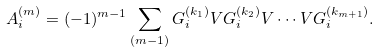<formula> <loc_0><loc_0><loc_500><loc_500>A _ { i } ^ { ( m ) } = ( - 1 ) ^ { m - 1 } \sum _ { ( m - 1 ) } G ^ { ( k _ { 1 } ) } _ { i } V G ^ { ( k _ { 2 } ) } _ { i } V \cdots V G ^ { ( k _ { m + 1 } ) } _ { i } .</formula> 